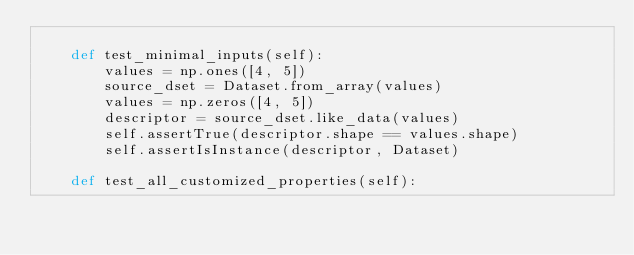Convert code to text. <code><loc_0><loc_0><loc_500><loc_500><_Python_>
    def test_minimal_inputs(self):
        values = np.ones([4, 5])
        source_dset = Dataset.from_array(values)
        values = np.zeros([4, 5])
        descriptor = source_dset.like_data(values)
        self.assertTrue(descriptor.shape == values.shape)
        self.assertIsInstance(descriptor, Dataset)

    def test_all_customized_properties(self):</code> 